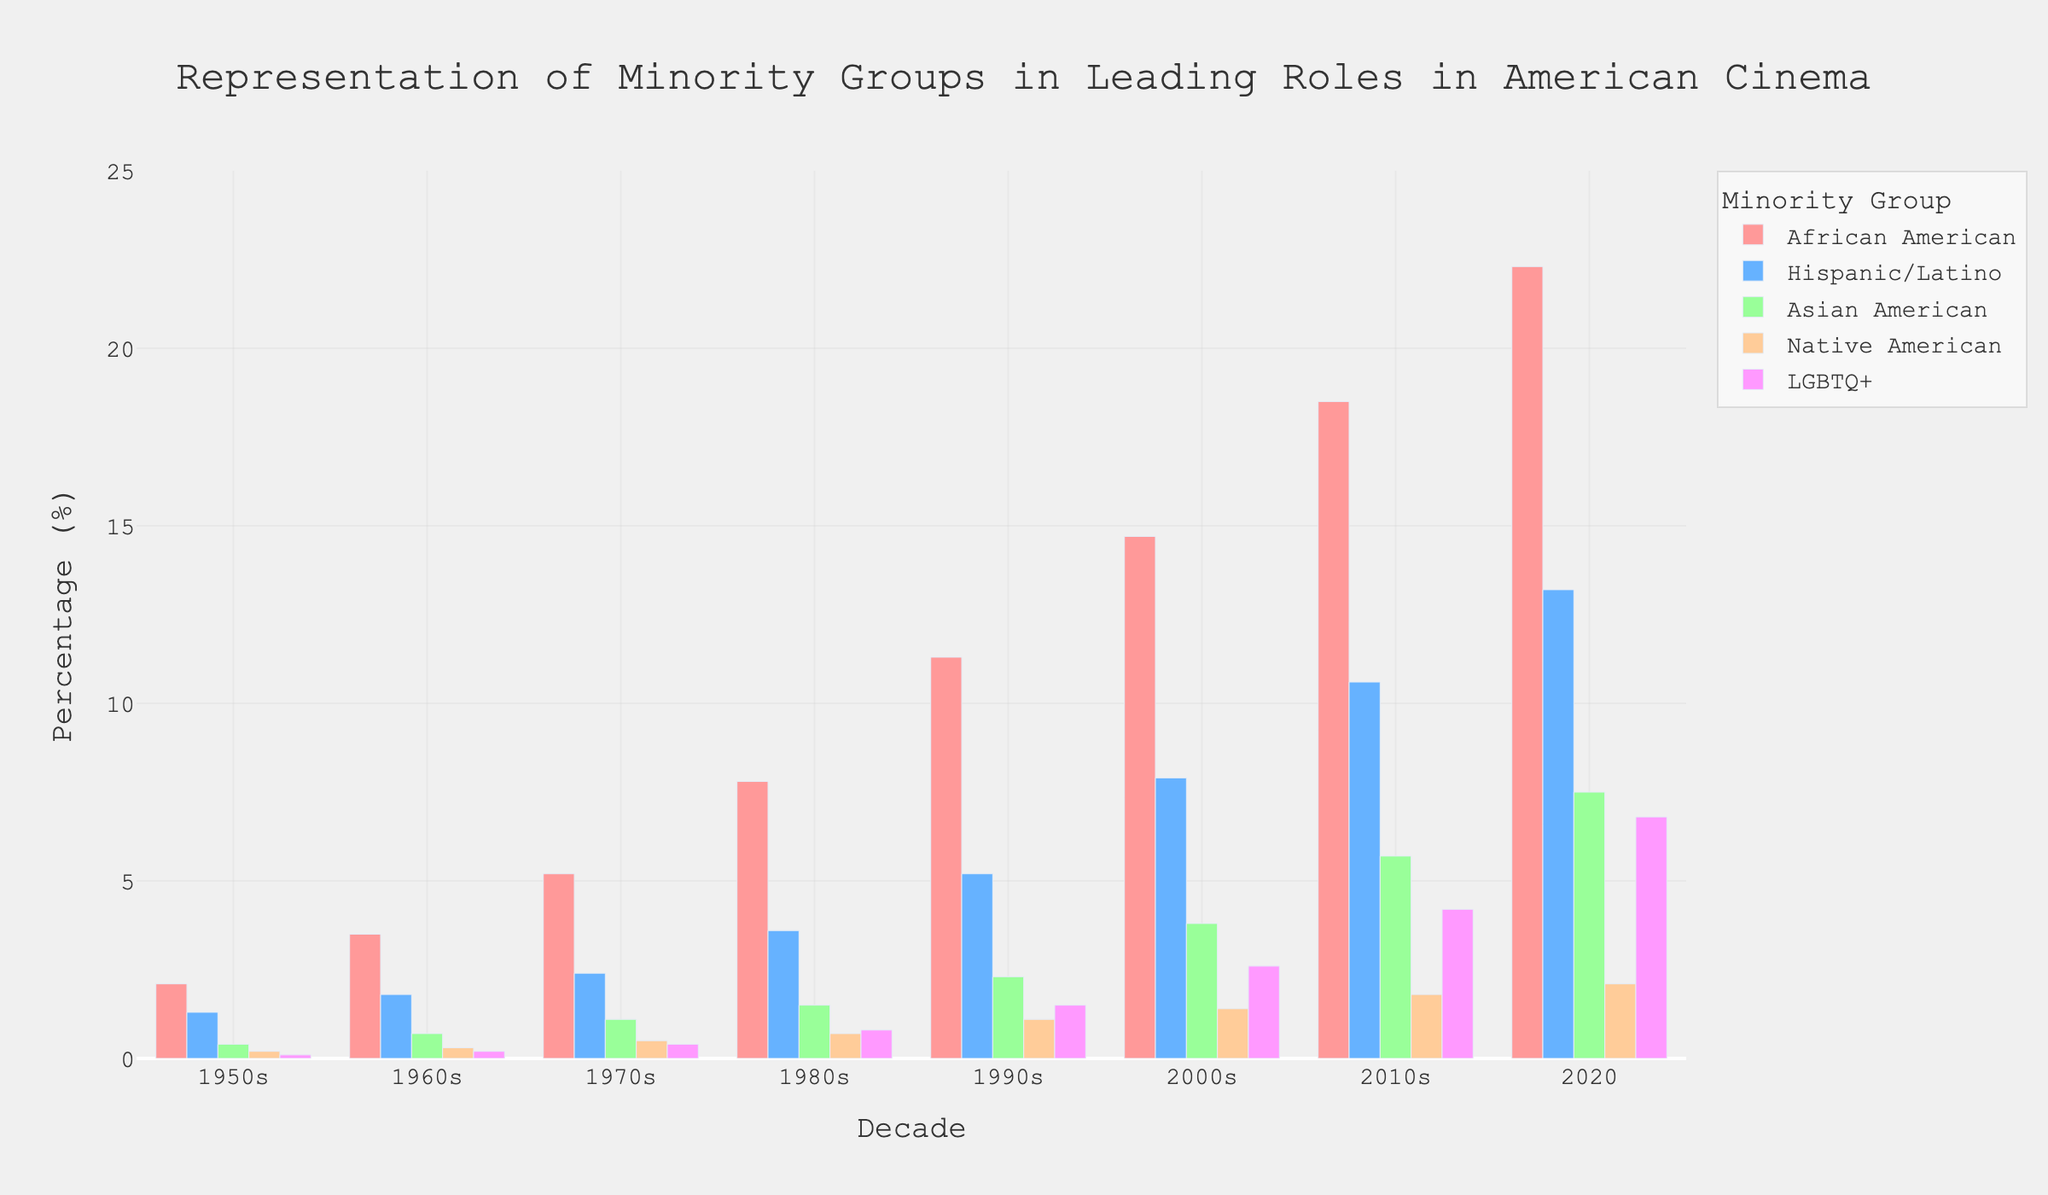What is the increase in percentage of African American leading roles from the 1950s to 2020? To find the increase, we subtract the percentage in the 1950s (2.1%) from the percentage in 2020 (22.3%). Calculation: 22.3% - 2.1% = 20.2%.
Answer: 20.2% Which minority group saw the greatest percentage increase in leading roles from the 1950s to 2020? We need to calculate the percentage increase for each group from the 1950s to 2020: African American: 22.3% - 2.1% = 20.2%, Hispanic/Latino: 13.2% - 1.3% = 11.9%, Asian American: 7.5% - 0.4% = 7.1%, Native American: 2.1% - 0.2% = 1.9%, LGBTQ+: 6.8% - 0.1% = 6.7%. African American has the highest increase of 20.2%.
Answer: African American Which minority group had the lowest representation in the 1950s? The group with the smallest percentage in the 1950s is the one with the lowest value in that column. The percentages are: African American 2.1%, Hispanic/Latino 1.3%, Asian American 0.4%, Native American 0.2%, LGBTQ+ 0.1%. Based on these values, the LGBTQ+ group had the lowest representation.
Answer: LGBTQ+ Compare the trend in representation of Hispanic/Latino and Asian American leading roles from 1980s to 2020. Which group had a higher increase? We calculate the increase for each group between 1980s and 2020. Hispanic/Latino: 13.2% - 3.6% = 9.6%, Asian American: 7.5% - 1.5% = 6.0%. Hispanic/Latino had a higher increase of 9.6%.
Answer: Hispanic/Latino What is the average percentage of Native American representation across all decades? Sum all the percentages for Native American (0.2+0.3+0.5+0.7+1.1+1.4+1.8+2.1) and divide by the number of data points (8). Calculation: (0.2+0.3+0.5+0.7+1.1+1.4+1.8+2.1) ÷ 8 = 1.0125%.
Answer: 1.01% Which decade saw the greatest increase in LGBTQ+ leading roles compared to the previous decade? We calculate the increase for each decade by subtracting the previous decade's percentage: 1960s-1950s: 0.2% - 0.1% = 0.1%, 1970s-1960s: 0.4% - 0.2% = 0.2%, 1980s-1970s: 0.8% - 0.4% = 0.4%, 1990s-1980s: 1.5% - 0.8% = 0.7%, 2000s-1990s: 2.6% - 1.5% = 1.1%, 2010s-2000s: 4.2% - 2.6% = 1.6%, 2020-2010s: 6.8% - 4.2% = 2.6%. The greatest increase was from 2010s to 2020.
Answer: 2010s to 2020 What percentage of leading roles were represented by African American and Hispanic/Latino groups combined in the 2010s? We add the percentages for African American (18.5%) and Hispanic/Latino (10.6%) in the 2010s. Calculation: 18.5% + 10.6% = 29.1%.
Answer: 29.1% Which group had the highest representation in the 2000s? We compare the percentages for each group in the 2000s: African American 14.7%, Hispanic/Latino 7.9%, Asian American 3.8%, Native American 1.4%, LGBTQ+ 2.6%. African American had the highest representation at 14.7%.
Answer: African American In which decade did Native American representation cross 1%? We look at the column for Native American to identify the decade where the percentage first exceeds 1%. The percentages are: 1950s: 0.2%, 1960s: 0.3%, 1970s: 0.5%, 1980s: 0.7%, 1990s: 1.1%. Native American representation crossed 1% in the 1990s.
Answer: 1990s 